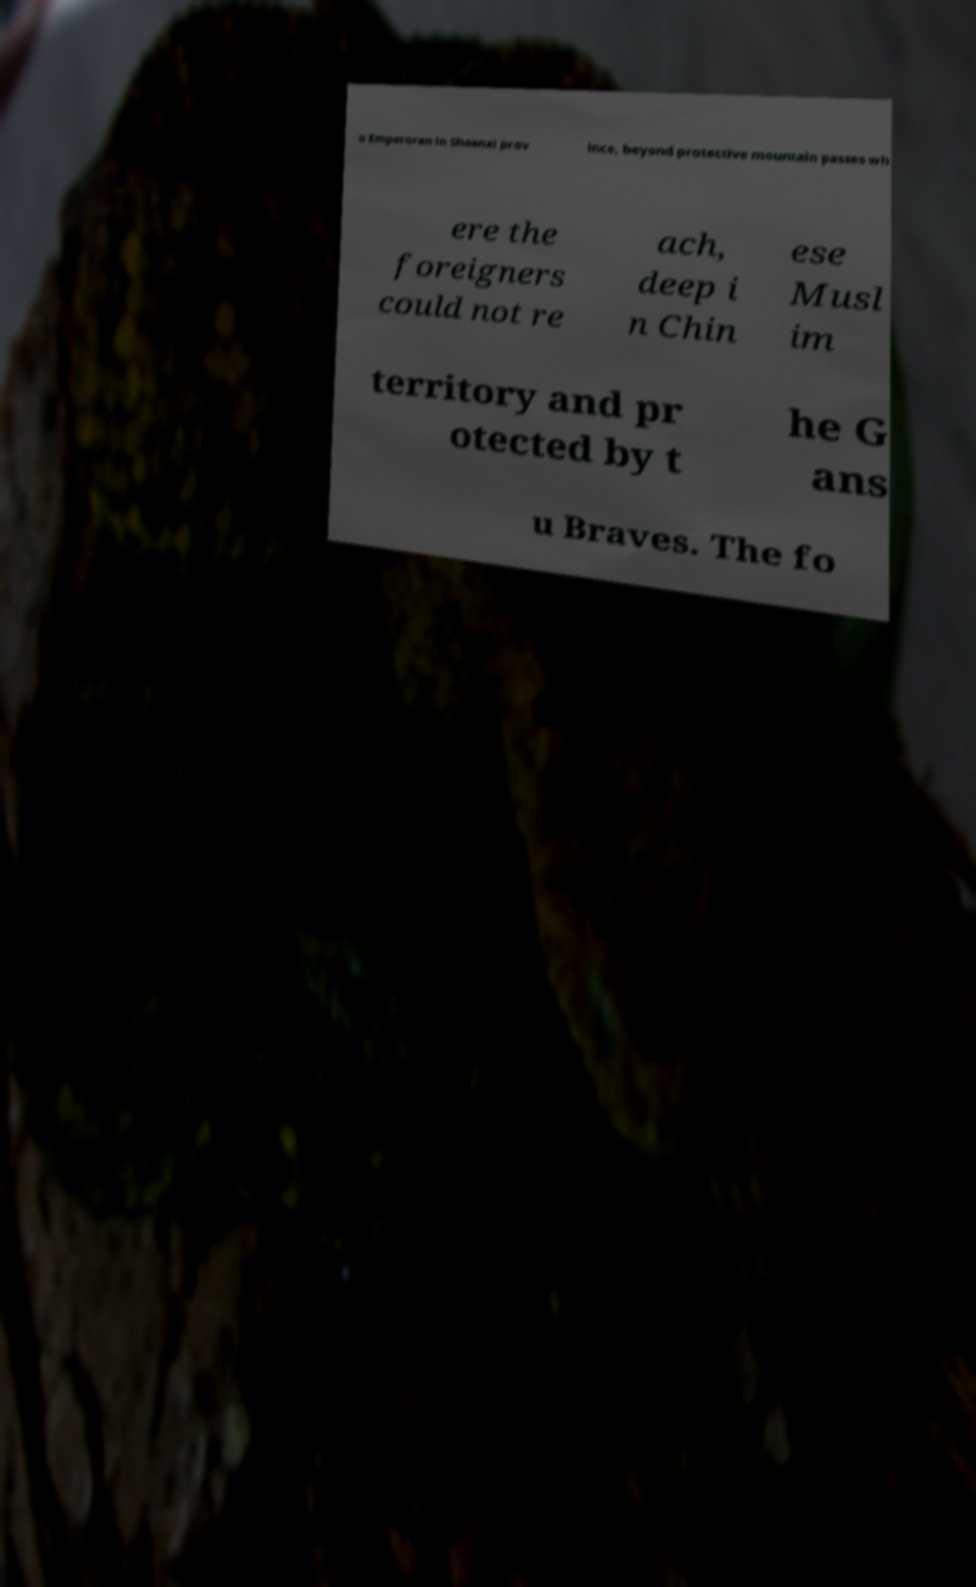Could you assist in decoding the text presented in this image and type it out clearly? u Emperoran in Shaanxi prov ince, beyond protective mountain passes wh ere the foreigners could not re ach, deep i n Chin ese Musl im territory and pr otected by t he G ans u Braves. The fo 